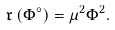Convert formula to latex. <formula><loc_0><loc_0><loc_500><loc_500>\mathfrak { r } \left ( \Phi ^ { \circ } \right ) & = \mu ^ { 2 } \Phi ^ { 2 } .</formula> 